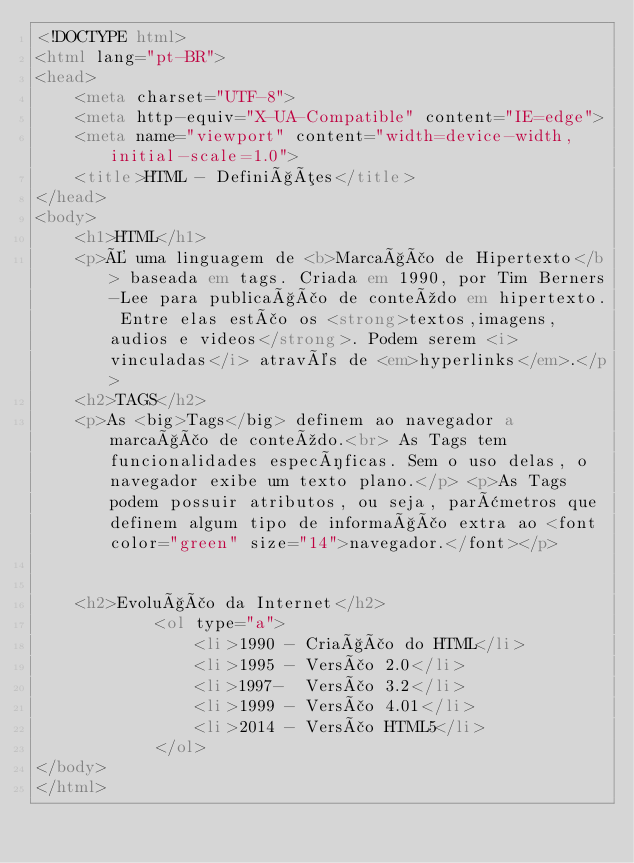Convert code to text. <code><loc_0><loc_0><loc_500><loc_500><_HTML_><!DOCTYPE html>
<html lang="pt-BR">
<head>
    <meta charset="UTF-8">
    <meta http-equiv="X-UA-Compatible" content="IE=edge">
    <meta name="viewport" content="width=device-width, initial-scale=1.0">
    <title>HTML - Definições</title>
</head>
<body>
    <h1>HTML</h1>
    <p>É uma linguagem de <b>Marcação de Hipertexto</b> baseada em tags. Criada em 1990, por Tim Berners-Lee para publicação de conteúdo em hipertexto. Entre elas estão os <strong>textos,imagens, audios e videos</strong>. Podem serem <i>vinculadas</i> através de <em>hyperlinks</em>.</p>
    <h2>TAGS</h2>
    <p>As <big>Tags</big> definem ao navegador a marcação de conteúdo.<br> As Tags tem funcionalidades específicas. Sem o uso delas, o navegador exibe um texto plano.</p> <p>As Tags podem possuir atributos, ou seja, parâmetros que definem algum tipo de informação extra ao <font color="green" size="14">navegador.</font></p>

    
    <h2>Evolução da Internet</h2>
            <ol type="a">
                <li>1990 - Criação do HTML</li>
                <li>1995 - Versão 2.0</li>
                <li>1997-  Versão 3.2</li>
                <li>1999 - Versão 4.01</li>
                <li>2014 - Versão HTML5</li> 
            </ol>
</body>
</html></code> 